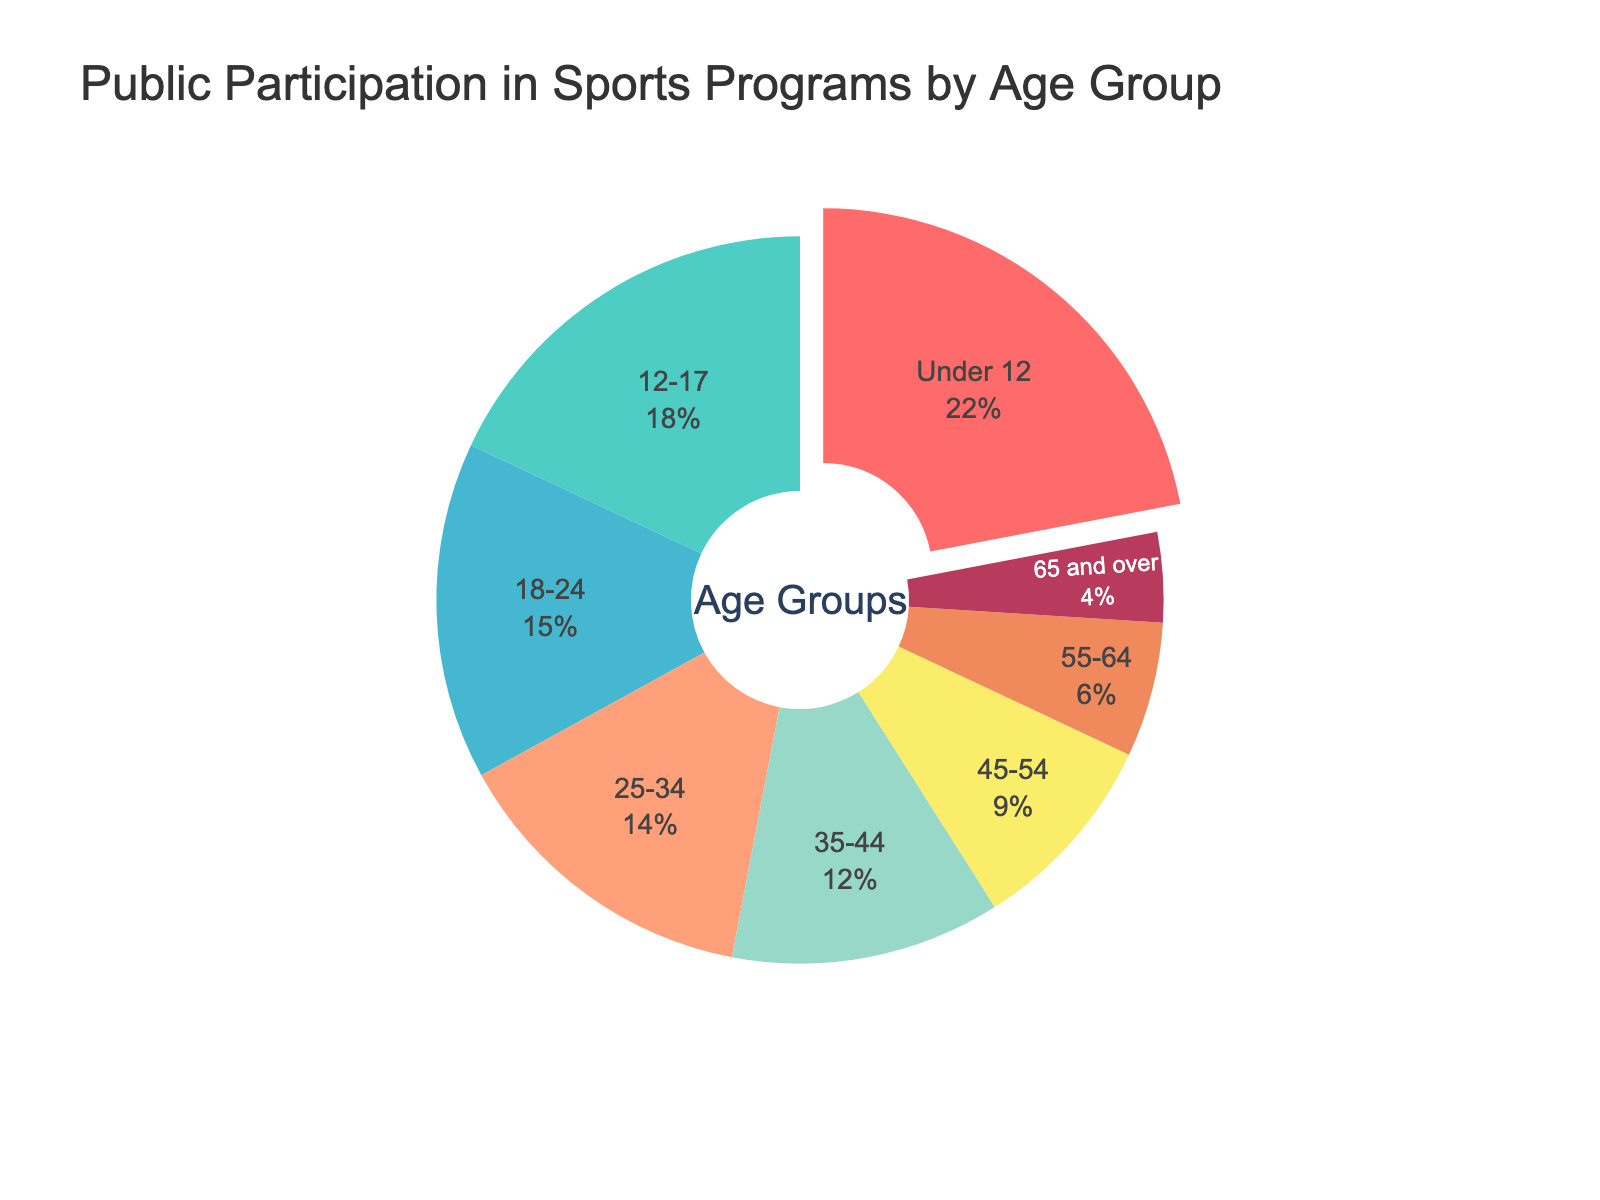What percentage of participants are under the age of 18? Add the participation percentages of the "Under 12" age group (22) and the "12-17" age group (18). The total is 22 + 18 = 40
Answer: 40% Which age group has the lowest participation? Find the smallest percentage in the data. The "65 and over" group has the lowest participation at 4%.
Answer: 65 and over How does the participation of the 18-24 age group compare to the 25-34 age group? Compare the percentages of the "18-24" age group (15) and the "25-34" age group (14). The participation of the "18-24" age group is higher by 1%.
Answer: 18-24 has higher participation Which age group occupies the largest segment with the red color? Look for the largest segment in red. The "Under 12" age group is the largest in red, with 22% participation.
Answer: Under 12 What is the combined participation percentage of the 35-44 and 45-54 age groups? Add the participation percentages of the "35-44" age group (12) and the "45-54" age group (9). The total is 12 + 9 = 21
Answer: 21% Is there more participation from people aged 55 and over or from people aged 25-34? Add the participation percentages of the groups "55-64" (6) and "65 and over" (4), then compare this sum (10) to the "25-34" age group (14). The "25-34" age group has more participation, 14 compared to 10.
Answer: 25-34 has more participation What is the difference in participation between the age groups "12-17" and "35-44"? Subtract the participation percentage of the "35-44" group (12) from the "12-17" group (18). The difference is 18 - 12 = 6
Answer: 6 What are the top three age groups in terms of participation percentage? Rank the participation percentages and select the top three: "Under 12" (22), "12-17" (18), and "18-24" (15).
Answer: Under 12, 12-17, 18-24 Which age group occupies the smallest segment with blue color? Look for the smallest segment in blue. The "55-64" age group is the smallest in blue, with 6% participation.
Answer: 55-64 